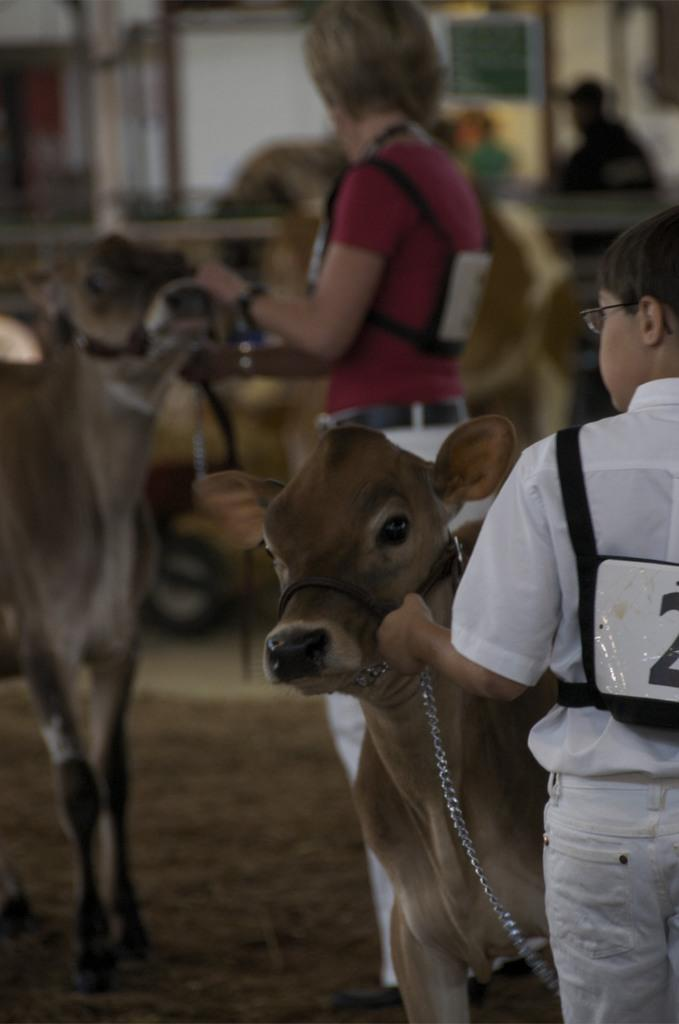How many people are in the image? There are two persons standing in the image. What other living creatures are present in the image? There are cows in the image. Can you describe the background of the image? The background of the image is blurred. What type of plants can be seen growing on the ship in the image? There is no ship present in the image, and therefore no plants growing on it. 